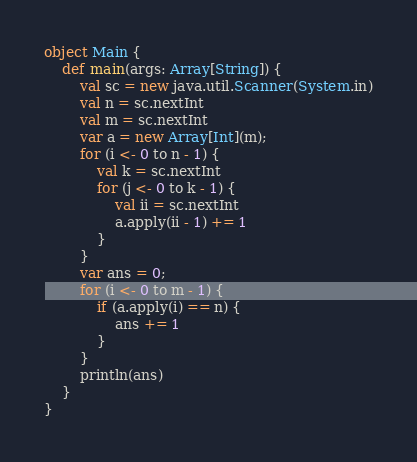<code> <loc_0><loc_0><loc_500><loc_500><_Scala_>object Main {
    def main(args: Array[String]) {
        val sc = new java.util.Scanner(System.in)
        val n = sc.nextInt
        val m = sc.nextInt
        var a = new Array[Int](m);
        for (i <- 0 to n - 1) {
            val k = sc.nextInt
            for (j <- 0 to k - 1) {
                val ii = sc.nextInt
                a.apply(ii - 1) += 1
            } 
        }
        var ans = 0;
        for (i <- 0 to m - 1) {
            if (a.apply(i) == n) {
                ans += 1
            }
        }
        println(ans)
    }
}</code> 